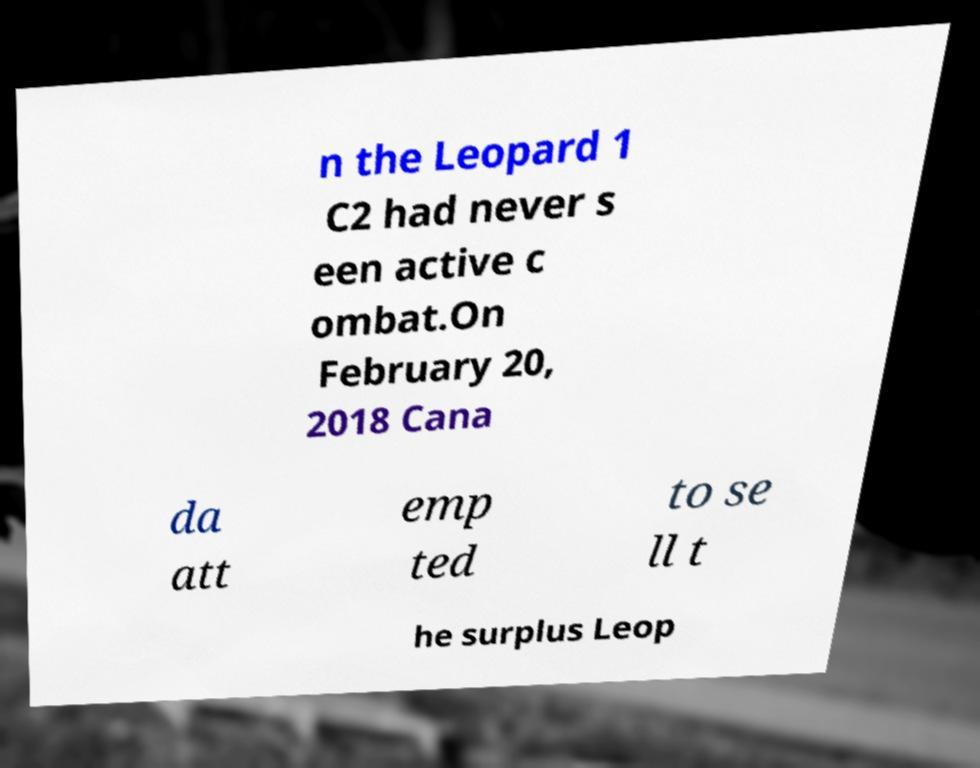There's text embedded in this image that I need extracted. Can you transcribe it verbatim? n the Leopard 1 C2 had never s een active c ombat.On February 20, 2018 Cana da att emp ted to se ll t he surplus Leop 